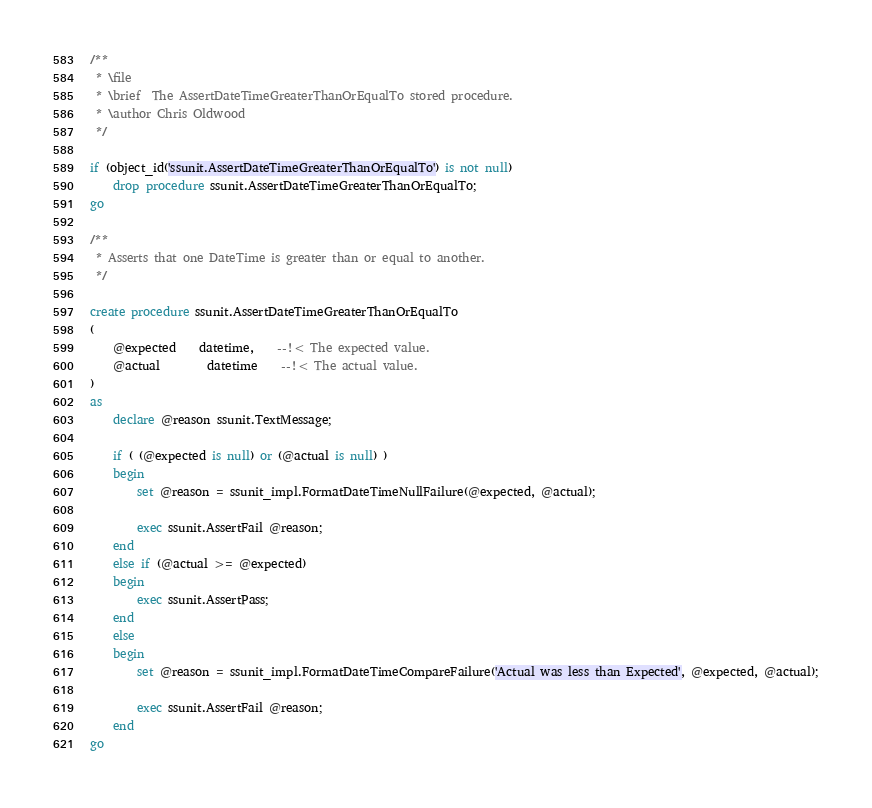<code> <loc_0><loc_0><loc_500><loc_500><_SQL_>/**
 * \file
 * \brief  The AssertDateTimeGreaterThanOrEqualTo stored procedure.
 * \author Chris Oldwood
 */

if (object_id('ssunit.AssertDateTimeGreaterThanOrEqualTo') is not null)
	drop procedure ssunit.AssertDateTimeGreaterThanOrEqualTo;
go

/**
 * Asserts that one DateTime is greater than or equal to another.
 */

create procedure ssunit.AssertDateTimeGreaterThanOrEqualTo
(
	@expected	datetime,	--!< The expected value.
	@actual		datetime	--!< The actual value.
)
as
	declare @reason ssunit.TextMessage;

	if ( (@expected is null) or (@actual is null) )
	begin
		set @reason = ssunit_impl.FormatDateTimeNullFailure(@expected, @actual);

		exec ssunit.AssertFail @reason;
	end
	else if (@actual >= @expected)
	begin
		exec ssunit.AssertPass;
	end
	else
	begin
		set @reason = ssunit_impl.FormatDateTimeCompareFailure('Actual was less than Expected', @expected, @actual);

		exec ssunit.AssertFail @reason;
	end
go
</code> 